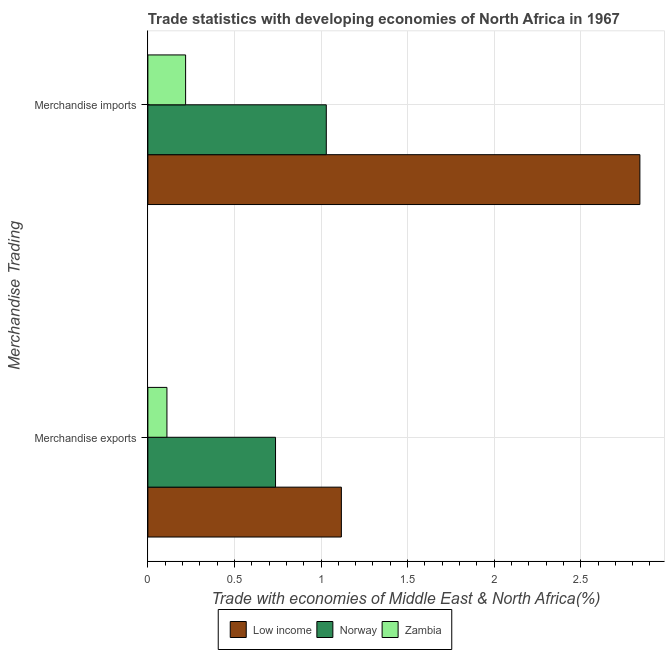How many groups of bars are there?
Your response must be concise. 2. Are the number of bars per tick equal to the number of legend labels?
Provide a short and direct response. Yes. How many bars are there on the 2nd tick from the bottom?
Offer a terse response. 3. What is the merchandise imports in Zambia?
Offer a very short reply. 0.22. Across all countries, what is the maximum merchandise exports?
Make the answer very short. 1.12. Across all countries, what is the minimum merchandise exports?
Your answer should be very brief. 0.11. In which country was the merchandise exports maximum?
Give a very brief answer. Low income. In which country was the merchandise imports minimum?
Provide a succinct answer. Zambia. What is the total merchandise imports in the graph?
Your response must be concise. 4.09. What is the difference between the merchandise imports in Low income and that in Zambia?
Ensure brevity in your answer.  2.62. What is the difference between the merchandise imports in Norway and the merchandise exports in Zambia?
Provide a short and direct response. 0.92. What is the average merchandise imports per country?
Ensure brevity in your answer.  1.36. What is the difference between the merchandise imports and merchandise exports in Zambia?
Provide a succinct answer. 0.11. In how many countries, is the merchandise exports greater than 1.7 %?
Your answer should be very brief. 0. What is the ratio of the merchandise exports in Norway to that in Zambia?
Offer a very short reply. 6.7. Is the merchandise imports in Zambia less than that in Low income?
Your answer should be compact. Yes. What does the 2nd bar from the top in Merchandise exports represents?
Offer a terse response. Norway. What does the 1st bar from the bottom in Merchandise exports represents?
Keep it short and to the point. Low income. Are the values on the major ticks of X-axis written in scientific E-notation?
Your answer should be compact. No. Does the graph contain grids?
Your response must be concise. Yes. How are the legend labels stacked?
Provide a short and direct response. Horizontal. What is the title of the graph?
Keep it short and to the point. Trade statistics with developing economies of North Africa in 1967. What is the label or title of the X-axis?
Offer a terse response. Trade with economies of Middle East & North Africa(%). What is the label or title of the Y-axis?
Offer a terse response. Merchandise Trading. What is the Trade with economies of Middle East & North Africa(%) of Low income in Merchandise exports?
Keep it short and to the point. 1.12. What is the Trade with economies of Middle East & North Africa(%) of Norway in Merchandise exports?
Ensure brevity in your answer.  0.74. What is the Trade with economies of Middle East & North Africa(%) in Zambia in Merchandise exports?
Your answer should be compact. 0.11. What is the Trade with economies of Middle East & North Africa(%) in Low income in Merchandise imports?
Give a very brief answer. 2.84. What is the Trade with economies of Middle East & North Africa(%) in Norway in Merchandise imports?
Offer a terse response. 1.03. What is the Trade with economies of Middle East & North Africa(%) in Zambia in Merchandise imports?
Give a very brief answer. 0.22. Across all Merchandise Trading, what is the maximum Trade with economies of Middle East & North Africa(%) of Low income?
Offer a very short reply. 2.84. Across all Merchandise Trading, what is the maximum Trade with economies of Middle East & North Africa(%) of Norway?
Make the answer very short. 1.03. Across all Merchandise Trading, what is the maximum Trade with economies of Middle East & North Africa(%) of Zambia?
Your answer should be compact. 0.22. Across all Merchandise Trading, what is the minimum Trade with economies of Middle East & North Africa(%) in Low income?
Make the answer very short. 1.12. Across all Merchandise Trading, what is the minimum Trade with economies of Middle East & North Africa(%) in Norway?
Give a very brief answer. 0.74. Across all Merchandise Trading, what is the minimum Trade with economies of Middle East & North Africa(%) in Zambia?
Offer a very short reply. 0.11. What is the total Trade with economies of Middle East & North Africa(%) in Low income in the graph?
Offer a very short reply. 3.96. What is the total Trade with economies of Middle East & North Africa(%) of Norway in the graph?
Your response must be concise. 1.77. What is the total Trade with economies of Middle East & North Africa(%) in Zambia in the graph?
Your answer should be compact. 0.33. What is the difference between the Trade with economies of Middle East & North Africa(%) of Low income in Merchandise exports and that in Merchandise imports?
Ensure brevity in your answer.  -1.72. What is the difference between the Trade with economies of Middle East & North Africa(%) of Norway in Merchandise exports and that in Merchandise imports?
Keep it short and to the point. -0.29. What is the difference between the Trade with economies of Middle East & North Africa(%) in Zambia in Merchandise exports and that in Merchandise imports?
Keep it short and to the point. -0.11. What is the difference between the Trade with economies of Middle East & North Africa(%) of Low income in Merchandise exports and the Trade with economies of Middle East & North Africa(%) of Norway in Merchandise imports?
Make the answer very short. 0.09. What is the difference between the Trade with economies of Middle East & North Africa(%) in Low income in Merchandise exports and the Trade with economies of Middle East & North Africa(%) in Zambia in Merchandise imports?
Keep it short and to the point. 0.9. What is the difference between the Trade with economies of Middle East & North Africa(%) of Norway in Merchandise exports and the Trade with economies of Middle East & North Africa(%) of Zambia in Merchandise imports?
Your answer should be compact. 0.52. What is the average Trade with economies of Middle East & North Africa(%) in Low income per Merchandise Trading?
Make the answer very short. 1.98. What is the average Trade with economies of Middle East & North Africa(%) of Norway per Merchandise Trading?
Provide a short and direct response. 0.88. What is the average Trade with economies of Middle East & North Africa(%) of Zambia per Merchandise Trading?
Your answer should be very brief. 0.16. What is the difference between the Trade with economies of Middle East & North Africa(%) in Low income and Trade with economies of Middle East & North Africa(%) in Norway in Merchandise exports?
Your answer should be very brief. 0.38. What is the difference between the Trade with economies of Middle East & North Africa(%) of Low income and Trade with economies of Middle East & North Africa(%) of Zambia in Merchandise exports?
Offer a terse response. 1.01. What is the difference between the Trade with economies of Middle East & North Africa(%) in Norway and Trade with economies of Middle East & North Africa(%) in Zambia in Merchandise exports?
Your response must be concise. 0.63. What is the difference between the Trade with economies of Middle East & North Africa(%) in Low income and Trade with economies of Middle East & North Africa(%) in Norway in Merchandise imports?
Provide a succinct answer. 1.81. What is the difference between the Trade with economies of Middle East & North Africa(%) in Low income and Trade with economies of Middle East & North Africa(%) in Zambia in Merchandise imports?
Give a very brief answer. 2.62. What is the difference between the Trade with economies of Middle East & North Africa(%) of Norway and Trade with economies of Middle East & North Africa(%) of Zambia in Merchandise imports?
Provide a short and direct response. 0.81. What is the ratio of the Trade with economies of Middle East & North Africa(%) of Low income in Merchandise exports to that in Merchandise imports?
Keep it short and to the point. 0.39. What is the ratio of the Trade with economies of Middle East & North Africa(%) in Norway in Merchandise exports to that in Merchandise imports?
Your response must be concise. 0.72. What is the ratio of the Trade with economies of Middle East & North Africa(%) of Zambia in Merchandise exports to that in Merchandise imports?
Your response must be concise. 0.51. What is the difference between the highest and the second highest Trade with economies of Middle East & North Africa(%) in Low income?
Your response must be concise. 1.72. What is the difference between the highest and the second highest Trade with economies of Middle East & North Africa(%) of Norway?
Keep it short and to the point. 0.29. What is the difference between the highest and the second highest Trade with economies of Middle East & North Africa(%) of Zambia?
Keep it short and to the point. 0.11. What is the difference between the highest and the lowest Trade with economies of Middle East & North Africa(%) of Low income?
Offer a very short reply. 1.72. What is the difference between the highest and the lowest Trade with economies of Middle East & North Africa(%) of Norway?
Offer a very short reply. 0.29. What is the difference between the highest and the lowest Trade with economies of Middle East & North Africa(%) in Zambia?
Ensure brevity in your answer.  0.11. 